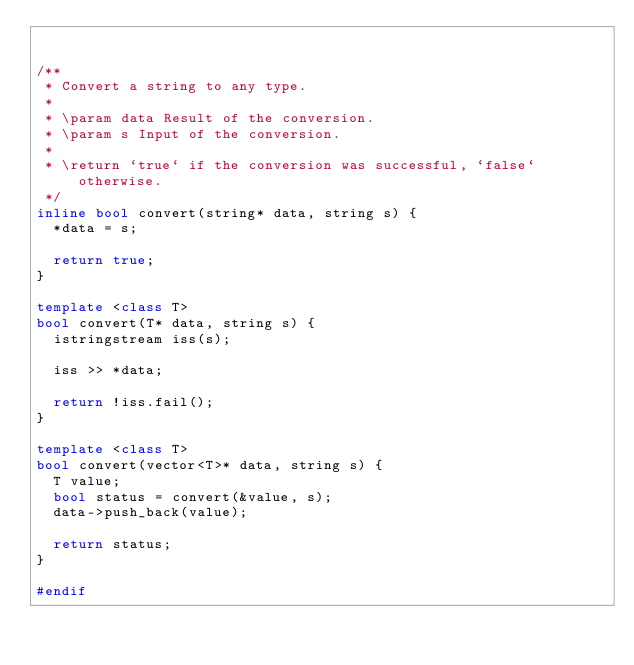Convert code to text. <code><loc_0><loc_0><loc_500><loc_500><_C++_>

/**
 * Convert a string to any type.
 *
 * \param data Result of the conversion.
 * \param s Input of the conversion.
 *
 * \return `true` if the conversion was successful, `false` otherwise.
 */
inline bool convert(string* data, string s) {
  *data = s;

  return true;
}

template <class T>
bool convert(T* data, string s) {
  istringstream iss(s);

  iss >> *data;

  return !iss.fail();
}

template <class T>
bool convert(vector<T>* data, string s) {
  T value;
  bool status = convert(&value, s);
  data->push_back(value);

  return status;
}

#endif
</code> 